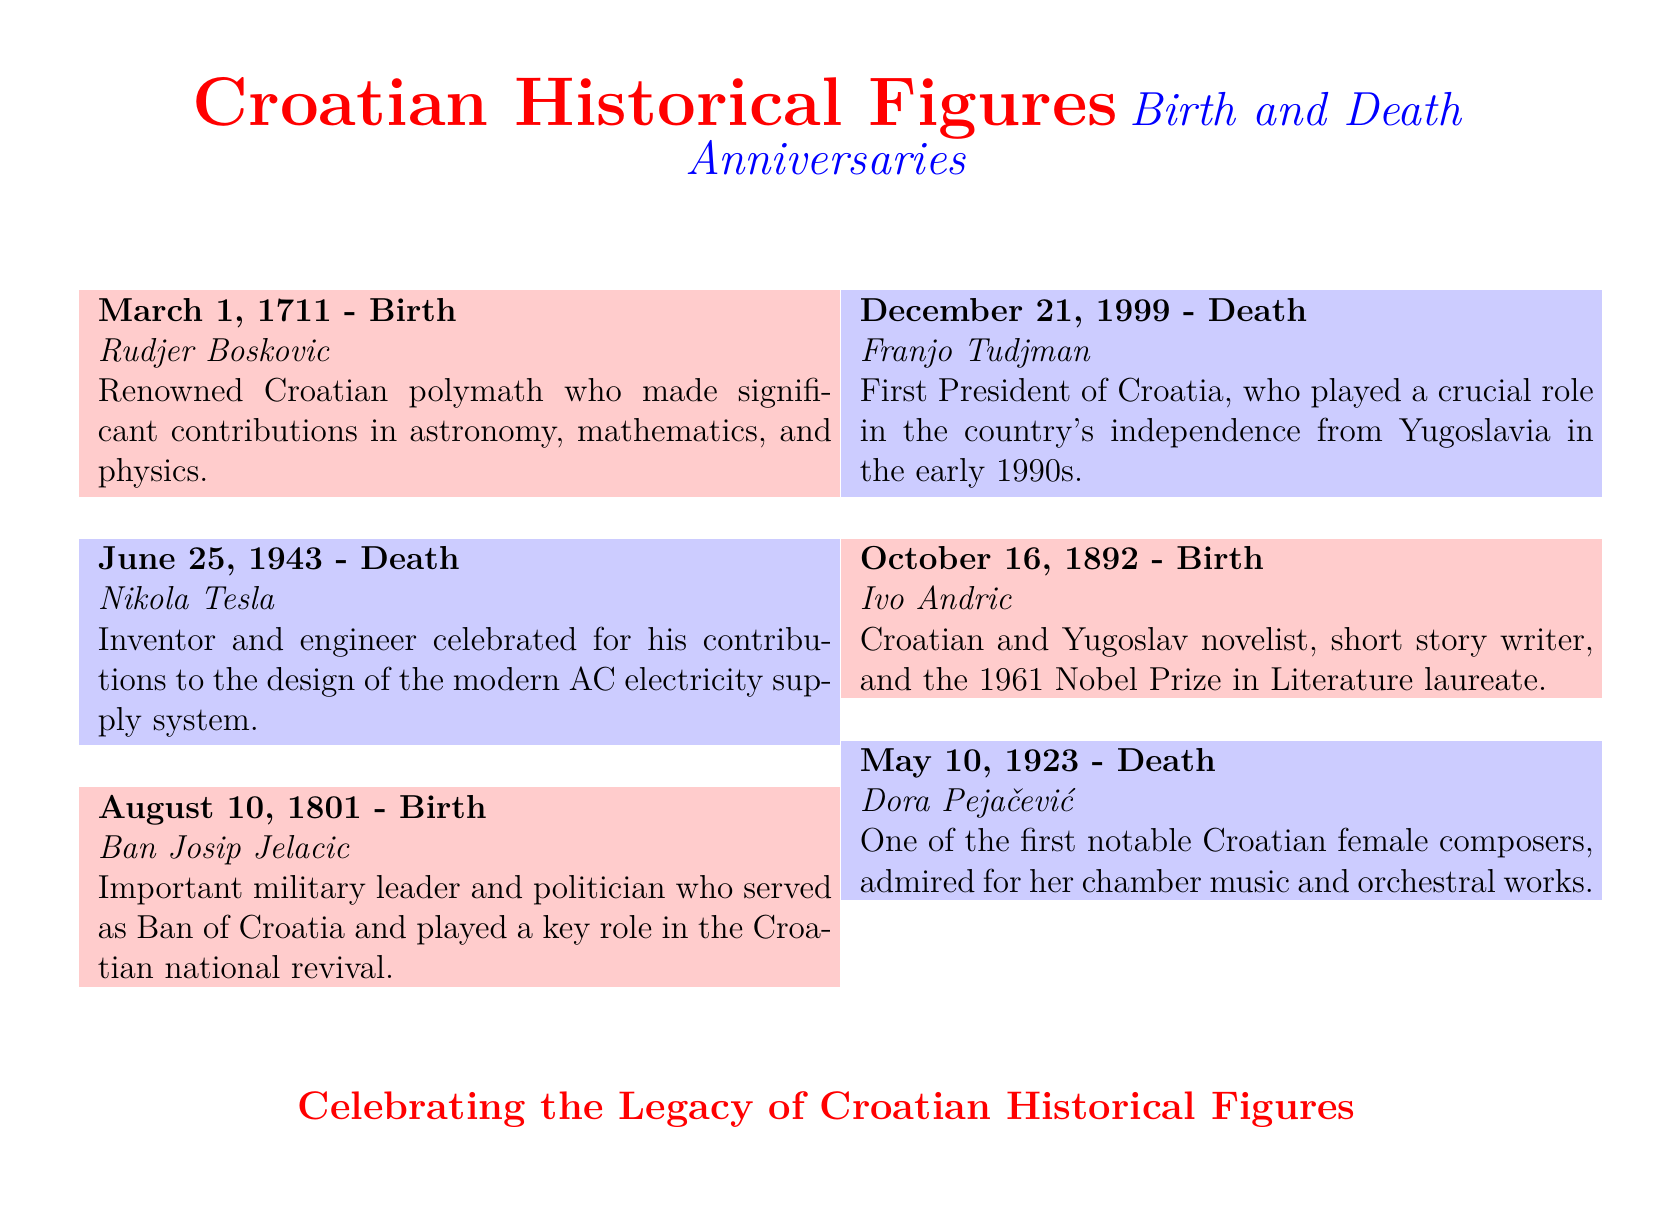What is the birth date of Rudjer Boskovic? The birth date of Rudjer Boskovic is specifically mentioned as March 1, 1711.
Answer: March 1, 1711 Who is celebrated for contributions to the AC electricity supply system? Nikola Tesla is noted in the document for his contributions to the design of the modern AC electricity supply system.
Answer: Nikola Tesla Which notable figure served as the first President of Croatia? Franjo Tudjman is highlighted as the first President of Croatia in the document.
Answer: Franjo Tudjman How many individuals have their birth dates listed in the document? The document presents a total of three birth dates, so the answer requires adding them up.
Answer: 3 On which date did Dora Pejačević pass away? The document specifies that Dora Pejačević died on May 10, 1923.
Answer: May 10, 1923 What common theme is celebrated in this calendar? The document celebrates the legacy of Croatian historical figures, as stated in the conclusion.
Answer: Legacy of Croatian historical figures Who was Ban Josip Jelacic? Ban Josip Jelacic is described as an important military leader and politician in the document.
Answer: Military leader and politician Which individual was born on October 16? The document indicates that Ivo Andric was born on October 16, 1892.
Answer: Ivo Andric 